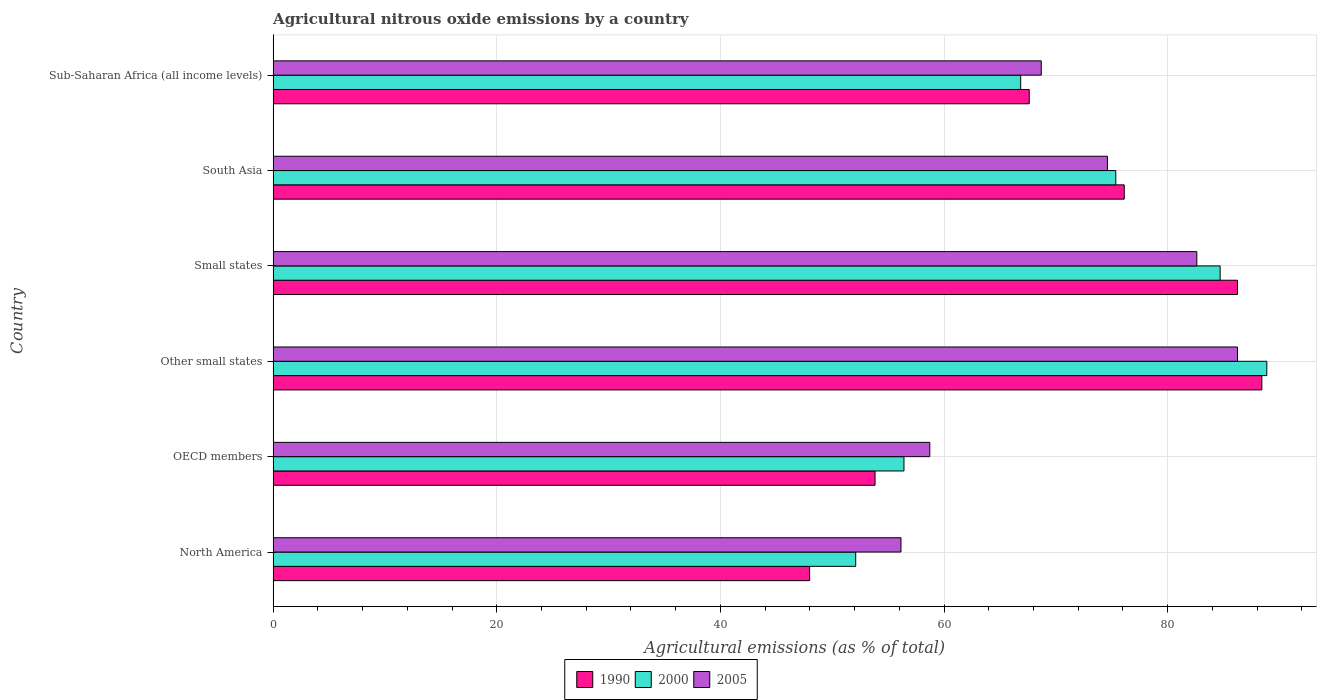How many groups of bars are there?
Offer a very short reply. 6. Are the number of bars on each tick of the Y-axis equal?
Your response must be concise. Yes. How many bars are there on the 2nd tick from the bottom?
Offer a terse response. 3. What is the amount of agricultural nitrous oxide emitted in 2005 in Sub-Saharan Africa (all income levels)?
Your response must be concise. 68.7. Across all countries, what is the maximum amount of agricultural nitrous oxide emitted in 1990?
Offer a very short reply. 88.42. Across all countries, what is the minimum amount of agricultural nitrous oxide emitted in 1990?
Offer a very short reply. 47.98. In which country was the amount of agricultural nitrous oxide emitted in 1990 maximum?
Offer a very short reply. Other small states. What is the total amount of agricultural nitrous oxide emitted in 2000 in the graph?
Ensure brevity in your answer.  424.3. What is the difference between the amount of agricultural nitrous oxide emitted in 2005 in North America and that in Sub-Saharan Africa (all income levels)?
Provide a short and direct response. -12.54. What is the difference between the amount of agricultural nitrous oxide emitted in 2000 in Sub-Saharan Africa (all income levels) and the amount of agricultural nitrous oxide emitted in 1990 in Small states?
Keep it short and to the point. -19.39. What is the average amount of agricultural nitrous oxide emitted in 2005 per country?
Keep it short and to the point. 71.17. What is the difference between the amount of agricultural nitrous oxide emitted in 2005 and amount of agricultural nitrous oxide emitted in 2000 in OECD members?
Offer a very short reply. 2.31. In how many countries, is the amount of agricultural nitrous oxide emitted in 2000 greater than 72 %?
Offer a very short reply. 3. What is the ratio of the amount of agricultural nitrous oxide emitted in 2005 in North America to that in Other small states?
Offer a very short reply. 0.65. Is the difference between the amount of agricultural nitrous oxide emitted in 2005 in Other small states and South Asia greater than the difference between the amount of agricultural nitrous oxide emitted in 2000 in Other small states and South Asia?
Provide a short and direct response. No. What is the difference between the highest and the second highest amount of agricultural nitrous oxide emitted in 2000?
Provide a short and direct response. 4.17. What is the difference between the highest and the lowest amount of agricultural nitrous oxide emitted in 2000?
Keep it short and to the point. 36.77. In how many countries, is the amount of agricultural nitrous oxide emitted in 1990 greater than the average amount of agricultural nitrous oxide emitted in 1990 taken over all countries?
Offer a terse response. 3. Is the sum of the amount of agricultural nitrous oxide emitted in 2000 in North America and OECD members greater than the maximum amount of agricultural nitrous oxide emitted in 2005 across all countries?
Offer a very short reply. Yes. What does the 2nd bar from the top in North America represents?
Keep it short and to the point. 2000. What does the 1st bar from the bottom in OECD members represents?
Your answer should be compact. 1990. How many countries are there in the graph?
Make the answer very short. 6. Are the values on the major ticks of X-axis written in scientific E-notation?
Your answer should be very brief. No. What is the title of the graph?
Make the answer very short. Agricultural nitrous oxide emissions by a country. Does "2000" appear as one of the legend labels in the graph?
Offer a very short reply. Yes. What is the label or title of the X-axis?
Offer a very short reply. Agricultural emissions (as % of total). What is the label or title of the Y-axis?
Make the answer very short. Country. What is the Agricultural emissions (as % of total) of 1990 in North America?
Provide a succinct answer. 47.98. What is the Agricultural emissions (as % of total) in 2000 in North America?
Give a very brief answer. 52.1. What is the Agricultural emissions (as % of total) of 2005 in North America?
Provide a succinct answer. 56.15. What is the Agricultural emissions (as % of total) of 1990 in OECD members?
Make the answer very short. 53.83. What is the Agricultural emissions (as % of total) of 2000 in OECD members?
Offer a very short reply. 56.42. What is the Agricultural emissions (as % of total) of 2005 in OECD members?
Make the answer very short. 58.73. What is the Agricultural emissions (as % of total) in 1990 in Other small states?
Offer a terse response. 88.42. What is the Agricultural emissions (as % of total) in 2000 in Other small states?
Keep it short and to the point. 88.87. What is the Agricultural emissions (as % of total) in 2005 in Other small states?
Ensure brevity in your answer.  86.25. What is the Agricultural emissions (as % of total) in 1990 in Small states?
Ensure brevity in your answer.  86.24. What is the Agricultural emissions (as % of total) of 2000 in Small states?
Offer a terse response. 84.69. What is the Agricultural emissions (as % of total) in 2005 in Small states?
Keep it short and to the point. 82.61. What is the Agricultural emissions (as % of total) in 1990 in South Asia?
Give a very brief answer. 76.12. What is the Agricultural emissions (as % of total) in 2000 in South Asia?
Offer a terse response. 75.36. What is the Agricultural emissions (as % of total) in 2005 in South Asia?
Give a very brief answer. 74.62. What is the Agricultural emissions (as % of total) in 1990 in Sub-Saharan Africa (all income levels)?
Offer a terse response. 67.62. What is the Agricultural emissions (as % of total) in 2000 in Sub-Saharan Africa (all income levels)?
Make the answer very short. 66.86. What is the Agricultural emissions (as % of total) of 2005 in Sub-Saharan Africa (all income levels)?
Make the answer very short. 68.7. Across all countries, what is the maximum Agricultural emissions (as % of total) of 1990?
Your answer should be very brief. 88.42. Across all countries, what is the maximum Agricultural emissions (as % of total) of 2000?
Provide a short and direct response. 88.87. Across all countries, what is the maximum Agricultural emissions (as % of total) in 2005?
Give a very brief answer. 86.25. Across all countries, what is the minimum Agricultural emissions (as % of total) of 1990?
Your response must be concise. 47.98. Across all countries, what is the minimum Agricultural emissions (as % of total) of 2000?
Your answer should be compact. 52.1. Across all countries, what is the minimum Agricultural emissions (as % of total) in 2005?
Offer a very short reply. 56.15. What is the total Agricultural emissions (as % of total) of 1990 in the graph?
Ensure brevity in your answer.  420.22. What is the total Agricultural emissions (as % of total) in 2000 in the graph?
Your response must be concise. 424.3. What is the total Agricultural emissions (as % of total) of 2005 in the graph?
Your answer should be compact. 427.05. What is the difference between the Agricultural emissions (as % of total) in 1990 in North America and that in OECD members?
Your response must be concise. -5.85. What is the difference between the Agricultural emissions (as % of total) in 2000 in North America and that in OECD members?
Provide a succinct answer. -4.32. What is the difference between the Agricultural emissions (as % of total) in 2005 in North America and that in OECD members?
Make the answer very short. -2.58. What is the difference between the Agricultural emissions (as % of total) of 1990 in North America and that in Other small states?
Offer a terse response. -40.44. What is the difference between the Agricultural emissions (as % of total) of 2000 in North America and that in Other small states?
Your answer should be compact. -36.77. What is the difference between the Agricultural emissions (as % of total) in 2005 in North America and that in Other small states?
Give a very brief answer. -30.09. What is the difference between the Agricultural emissions (as % of total) in 1990 in North America and that in Small states?
Offer a terse response. -38.26. What is the difference between the Agricultural emissions (as % of total) of 2000 in North America and that in Small states?
Offer a terse response. -32.59. What is the difference between the Agricultural emissions (as % of total) of 2005 in North America and that in Small states?
Your answer should be very brief. -26.46. What is the difference between the Agricultural emissions (as % of total) of 1990 in North America and that in South Asia?
Provide a succinct answer. -28.14. What is the difference between the Agricultural emissions (as % of total) of 2000 in North America and that in South Asia?
Give a very brief answer. -23.26. What is the difference between the Agricultural emissions (as % of total) in 2005 in North America and that in South Asia?
Your answer should be compact. -18.46. What is the difference between the Agricultural emissions (as % of total) of 1990 in North America and that in Sub-Saharan Africa (all income levels)?
Keep it short and to the point. -19.64. What is the difference between the Agricultural emissions (as % of total) of 2000 in North America and that in Sub-Saharan Africa (all income levels)?
Offer a terse response. -14.76. What is the difference between the Agricultural emissions (as % of total) in 2005 in North America and that in Sub-Saharan Africa (all income levels)?
Provide a short and direct response. -12.54. What is the difference between the Agricultural emissions (as % of total) of 1990 in OECD members and that in Other small states?
Offer a terse response. -34.59. What is the difference between the Agricultural emissions (as % of total) of 2000 in OECD members and that in Other small states?
Keep it short and to the point. -32.45. What is the difference between the Agricultural emissions (as % of total) of 2005 in OECD members and that in Other small states?
Your response must be concise. -27.52. What is the difference between the Agricultural emissions (as % of total) of 1990 in OECD members and that in Small states?
Provide a succinct answer. -32.41. What is the difference between the Agricultural emissions (as % of total) in 2000 in OECD members and that in Small states?
Your answer should be very brief. -28.28. What is the difference between the Agricultural emissions (as % of total) in 2005 in OECD members and that in Small states?
Offer a very short reply. -23.88. What is the difference between the Agricultural emissions (as % of total) in 1990 in OECD members and that in South Asia?
Provide a short and direct response. -22.29. What is the difference between the Agricultural emissions (as % of total) of 2000 in OECD members and that in South Asia?
Provide a succinct answer. -18.94. What is the difference between the Agricultural emissions (as % of total) of 2005 in OECD members and that in South Asia?
Offer a very short reply. -15.89. What is the difference between the Agricultural emissions (as % of total) in 1990 in OECD members and that in Sub-Saharan Africa (all income levels)?
Your answer should be compact. -13.79. What is the difference between the Agricultural emissions (as % of total) of 2000 in OECD members and that in Sub-Saharan Africa (all income levels)?
Provide a short and direct response. -10.44. What is the difference between the Agricultural emissions (as % of total) in 2005 in OECD members and that in Sub-Saharan Africa (all income levels)?
Your answer should be very brief. -9.97. What is the difference between the Agricultural emissions (as % of total) of 1990 in Other small states and that in Small states?
Offer a terse response. 2.18. What is the difference between the Agricultural emissions (as % of total) of 2000 in Other small states and that in Small states?
Offer a very short reply. 4.17. What is the difference between the Agricultural emissions (as % of total) of 2005 in Other small states and that in Small states?
Provide a short and direct response. 3.64. What is the difference between the Agricultural emissions (as % of total) of 1990 in Other small states and that in South Asia?
Offer a terse response. 12.31. What is the difference between the Agricultural emissions (as % of total) of 2000 in Other small states and that in South Asia?
Provide a short and direct response. 13.51. What is the difference between the Agricultural emissions (as % of total) of 2005 in Other small states and that in South Asia?
Keep it short and to the point. 11.63. What is the difference between the Agricultural emissions (as % of total) of 1990 in Other small states and that in Sub-Saharan Africa (all income levels)?
Your response must be concise. 20.8. What is the difference between the Agricultural emissions (as % of total) of 2000 in Other small states and that in Sub-Saharan Africa (all income levels)?
Your answer should be very brief. 22.01. What is the difference between the Agricultural emissions (as % of total) of 2005 in Other small states and that in Sub-Saharan Africa (all income levels)?
Ensure brevity in your answer.  17.55. What is the difference between the Agricultural emissions (as % of total) of 1990 in Small states and that in South Asia?
Your response must be concise. 10.12. What is the difference between the Agricultural emissions (as % of total) in 2000 in Small states and that in South Asia?
Provide a short and direct response. 9.33. What is the difference between the Agricultural emissions (as % of total) of 2005 in Small states and that in South Asia?
Provide a succinct answer. 7.99. What is the difference between the Agricultural emissions (as % of total) of 1990 in Small states and that in Sub-Saharan Africa (all income levels)?
Offer a very short reply. 18.62. What is the difference between the Agricultural emissions (as % of total) of 2000 in Small states and that in Sub-Saharan Africa (all income levels)?
Ensure brevity in your answer.  17.84. What is the difference between the Agricultural emissions (as % of total) in 2005 in Small states and that in Sub-Saharan Africa (all income levels)?
Keep it short and to the point. 13.91. What is the difference between the Agricultural emissions (as % of total) in 1990 in South Asia and that in Sub-Saharan Africa (all income levels)?
Your response must be concise. 8.5. What is the difference between the Agricultural emissions (as % of total) in 2000 in South Asia and that in Sub-Saharan Africa (all income levels)?
Your answer should be very brief. 8.5. What is the difference between the Agricultural emissions (as % of total) of 2005 in South Asia and that in Sub-Saharan Africa (all income levels)?
Offer a very short reply. 5.92. What is the difference between the Agricultural emissions (as % of total) of 1990 in North America and the Agricultural emissions (as % of total) of 2000 in OECD members?
Keep it short and to the point. -8.44. What is the difference between the Agricultural emissions (as % of total) in 1990 in North America and the Agricultural emissions (as % of total) in 2005 in OECD members?
Provide a succinct answer. -10.75. What is the difference between the Agricultural emissions (as % of total) of 2000 in North America and the Agricultural emissions (as % of total) of 2005 in OECD members?
Keep it short and to the point. -6.63. What is the difference between the Agricultural emissions (as % of total) in 1990 in North America and the Agricultural emissions (as % of total) in 2000 in Other small states?
Give a very brief answer. -40.89. What is the difference between the Agricultural emissions (as % of total) in 1990 in North America and the Agricultural emissions (as % of total) in 2005 in Other small states?
Make the answer very short. -38.26. What is the difference between the Agricultural emissions (as % of total) of 2000 in North America and the Agricultural emissions (as % of total) of 2005 in Other small states?
Ensure brevity in your answer.  -34.14. What is the difference between the Agricultural emissions (as % of total) in 1990 in North America and the Agricultural emissions (as % of total) in 2000 in Small states?
Keep it short and to the point. -36.71. What is the difference between the Agricultural emissions (as % of total) in 1990 in North America and the Agricultural emissions (as % of total) in 2005 in Small states?
Make the answer very short. -34.63. What is the difference between the Agricultural emissions (as % of total) in 2000 in North America and the Agricultural emissions (as % of total) in 2005 in Small states?
Give a very brief answer. -30.51. What is the difference between the Agricultural emissions (as % of total) of 1990 in North America and the Agricultural emissions (as % of total) of 2000 in South Asia?
Offer a terse response. -27.38. What is the difference between the Agricultural emissions (as % of total) in 1990 in North America and the Agricultural emissions (as % of total) in 2005 in South Asia?
Make the answer very short. -26.64. What is the difference between the Agricultural emissions (as % of total) in 2000 in North America and the Agricultural emissions (as % of total) in 2005 in South Asia?
Your answer should be very brief. -22.51. What is the difference between the Agricultural emissions (as % of total) of 1990 in North America and the Agricultural emissions (as % of total) of 2000 in Sub-Saharan Africa (all income levels)?
Your answer should be very brief. -18.88. What is the difference between the Agricultural emissions (as % of total) in 1990 in North America and the Agricultural emissions (as % of total) in 2005 in Sub-Saharan Africa (all income levels)?
Offer a very short reply. -20.72. What is the difference between the Agricultural emissions (as % of total) in 2000 in North America and the Agricultural emissions (as % of total) in 2005 in Sub-Saharan Africa (all income levels)?
Keep it short and to the point. -16.6. What is the difference between the Agricultural emissions (as % of total) of 1990 in OECD members and the Agricultural emissions (as % of total) of 2000 in Other small states?
Keep it short and to the point. -35.04. What is the difference between the Agricultural emissions (as % of total) in 1990 in OECD members and the Agricultural emissions (as % of total) in 2005 in Other small states?
Keep it short and to the point. -32.41. What is the difference between the Agricultural emissions (as % of total) of 2000 in OECD members and the Agricultural emissions (as % of total) of 2005 in Other small states?
Your answer should be compact. -29.83. What is the difference between the Agricultural emissions (as % of total) in 1990 in OECD members and the Agricultural emissions (as % of total) in 2000 in Small states?
Offer a very short reply. -30.86. What is the difference between the Agricultural emissions (as % of total) in 1990 in OECD members and the Agricultural emissions (as % of total) in 2005 in Small states?
Give a very brief answer. -28.78. What is the difference between the Agricultural emissions (as % of total) of 2000 in OECD members and the Agricultural emissions (as % of total) of 2005 in Small states?
Offer a terse response. -26.19. What is the difference between the Agricultural emissions (as % of total) in 1990 in OECD members and the Agricultural emissions (as % of total) in 2000 in South Asia?
Offer a very short reply. -21.53. What is the difference between the Agricultural emissions (as % of total) in 1990 in OECD members and the Agricultural emissions (as % of total) in 2005 in South Asia?
Your response must be concise. -20.78. What is the difference between the Agricultural emissions (as % of total) of 2000 in OECD members and the Agricultural emissions (as % of total) of 2005 in South Asia?
Give a very brief answer. -18.2. What is the difference between the Agricultural emissions (as % of total) of 1990 in OECD members and the Agricultural emissions (as % of total) of 2000 in Sub-Saharan Africa (all income levels)?
Your answer should be very brief. -13.03. What is the difference between the Agricultural emissions (as % of total) of 1990 in OECD members and the Agricultural emissions (as % of total) of 2005 in Sub-Saharan Africa (all income levels)?
Offer a very short reply. -14.86. What is the difference between the Agricultural emissions (as % of total) of 2000 in OECD members and the Agricultural emissions (as % of total) of 2005 in Sub-Saharan Africa (all income levels)?
Give a very brief answer. -12.28. What is the difference between the Agricultural emissions (as % of total) of 1990 in Other small states and the Agricultural emissions (as % of total) of 2000 in Small states?
Your response must be concise. 3.73. What is the difference between the Agricultural emissions (as % of total) of 1990 in Other small states and the Agricultural emissions (as % of total) of 2005 in Small states?
Provide a succinct answer. 5.82. What is the difference between the Agricultural emissions (as % of total) in 2000 in Other small states and the Agricultural emissions (as % of total) in 2005 in Small states?
Your answer should be compact. 6.26. What is the difference between the Agricultural emissions (as % of total) of 1990 in Other small states and the Agricultural emissions (as % of total) of 2000 in South Asia?
Offer a very short reply. 13.06. What is the difference between the Agricultural emissions (as % of total) of 1990 in Other small states and the Agricultural emissions (as % of total) of 2005 in South Asia?
Your response must be concise. 13.81. What is the difference between the Agricultural emissions (as % of total) in 2000 in Other small states and the Agricultural emissions (as % of total) in 2005 in South Asia?
Provide a succinct answer. 14.25. What is the difference between the Agricultural emissions (as % of total) in 1990 in Other small states and the Agricultural emissions (as % of total) in 2000 in Sub-Saharan Africa (all income levels)?
Offer a terse response. 21.57. What is the difference between the Agricultural emissions (as % of total) in 1990 in Other small states and the Agricultural emissions (as % of total) in 2005 in Sub-Saharan Africa (all income levels)?
Your answer should be very brief. 19.73. What is the difference between the Agricultural emissions (as % of total) in 2000 in Other small states and the Agricultural emissions (as % of total) in 2005 in Sub-Saharan Africa (all income levels)?
Provide a short and direct response. 20.17. What is the difference between the Agricultural emissions (as % of total) in 1990 in Small states and the Agricultural emissions (as % of total) in 2000 in South Asia?
Make the answer very short. 10.88. What is the difference between the Agricultural emissions (as % of total) of 1990 in Small states and the Agricultural emissions (as % of total) of 2005 in South Asia?
Your answer should be compact. 11.63. What is the difference between the Agricultural emissions (as % of total) of 2000 in Small states and the Agricultural emissions (as % of total) of 2005 in South Asia?
Make the answer very short. 10.08. What is the difference between the Agricultural emissions (as % of total) of 1990 in Small states and the Agricultural emissions (as % of total) of 2000 in Sub-Saharan Africa (all income levels)?
Provide a succinct answer. 19.39. What is the difference between the Agricultural emissions (as % of total) of 1990 in Small states and the Agricultural emissions (as % of total) of 2005 in Sub-Saharan Africa (all income levels)?
Give a very brief answer. 17.55. What is the difference between the Agricultural emissions (as % of total) of 2000 in Small states and the Agricultural emissions (as % of total) of 2005 in Sub-Saharan Africa (all income levels)?
Provide a short and direct response. 16. What is the difference between the Agricultural emissions (as % of total) of 1990 in South Asia and the Agricultural emissions (as % of total) of 2000 in Sub-Saharan Africa (all income levels)?
Provide a succinct answer. 9.26. What is the difference between the Agricultural emissions (as % of total) in 1990 in South Asia and the Agricultural emissions (as % of total) in 2005 in Sub-Saharan Africa (all income levels)?
Offer a very short reply. 7.42. What is the difference between the Agricultural emissions (as % of total) of 2000 in South Asia and the Agricultural emissions (as % of total) of 2005 in Sub-Saharan Africa (all income levels)?
Offer a terse response. 6.67. What is the average Agricultural emissions (as % of total) of 1990 per country?
Provide a succinct answer. 70.04. What is the average Agricultural emissions (as % of total) in 2000 per country?
Provide a succinct answer. 70.72. What is the average Agricultural emissions (as % of total) of 2005 per country?
Provide a short and direct response. 71.17. What is the difference between the Agricultural emissions (as % of total) in 1990 and Agricultural emissions (as % of total) in 2000 in North America?
Your answer should be compact. -4.12. What is the difference between the Agricultural emissions (as % of total) of 1990 and Agricultural emissions (as % of total) of 2005 in North America?
Your answer should be compact. -8.17. What is the difference between the Agricultural emissions (as % of total) of 2000 and Agricultural emissions (as % of total) of 2005 in North America?
Your answer should be very brief. -4.05. What is the difference between the Agricultural emissions (as % of total) of 1990 and Agricultural emissions (as % of total) of 2000 in OECD members?
Make the answer very short. -2.59. What is the difference between the Agricultural emissions (as % of total) of 1990 and Agricultural emissions (as % of total) of 2005 in OECD members?
Give a very brief answer. -4.9. What is the difference between the Agricultural emissions (as % of total) in 2000 and Agricultural emissions (as % of total) in 2005 in OECD members?
Offer a terse response. -2.31. What is the difference between the Agricultural emissions (as % of total) in 1990 and Agricultural emissions (as % of total) in 2000 in Other small states?
Give a very brief answer. -0.44. What is the difference between the Agricultural emissions (as % of total) in 1990 and Agricultural emissions (as % of total) in 2005 in Other small states?
Your answer should be very brief. 2.18. What is the difference between the Agricultural emissions (as % of total) of 2000 and Agricultural emissions (as % of total) of 2005 in Other small states?
Give a very brief answer. 2.62. What is the difference between the Agricultural emissions (as % of total) in 1990 and Agricultural emissions (as % of total) in 2000 in Small states?
Offer a terse response. 1.55. What is the difference between the Agricultural emissions (as % of total) in 1990 and Agricultural emissions (as % of total) in 2005 in Small states?
Your answer should be compact. 3.64. What is the difference between the Agricultural emissions (as % of total) in 2000 and Agricultural emissions (as % of total) in 2005 in Small states?
Your answer should be very brief. 2.09. What is the difference between the Agricultural emissions (as % of total) in 1990 and Agricultural emissions (as % of total) in 2000 in South Asia?
Your answer should be very brief. 0.76. What is the difference between the Agricultural emissions (as % of total) of 1990 and Agricultural emissions (as % of total) of 2005 in South Asia?
Give a very brief answer. 1.5. What is the difference between the Agricultural emissions (as % of total) of 2000 and Agricultural emissions (as % of total) of 2005 in South Asia?
Keep it short and to the point. 0.75. What is the difference between the Agricultural emissions (as % of total) in 1990 and Agricultural emissions (as % of total) in 2000 in Sub-Saharan Africa (all income levels)?
Your answer should be compact. 0.76. What is the difference between the Agricultural emissions (as % of total) of 1990 and Agricultural emissions (as % of total) of 2005 in Sub-Saharan Africa (all income levels)?
Offer a terse response. -1.08. What is the difference between the Agricultural emissions (as % of total) of 2000 and Agricultural emissions (as % of total) of 2005 in Sub-Saharan Africa (all income levels)?
Give a very brief answer. -1.84. What is the ratio of the Agricultural emissions (as % of total) of 1990 in North America to that in OECD members?
Provide a succinct answer. 0.89. What is the ratio of the Agricultural emissions (as % of total) in 2000 in North America to that in OECD members?
Ensure brevity in your answer.  0.92. What is the ratio of the Agricultural emissions (as % of total) of 2005 in North America to that in OECD members?
Give a very brief answer. 0.96. What is the ratio of the Agricultural emissions (as % of total) of 1990 in North America to that in Other small states?
Ensure brevity in your answer.  0.54. What is the ratio of the Agricultural emissions (as % of total) in 2000 in North America to that in Other small states?
Keep it short and to the point. 0.59. What is the ratio of the Agricultural emissions (as % of total) of 2005 in North America to that in Other small states?
Keep it short and to the point. 0.65. What is the ratio of the Agricultural emissions (as % of total) in 1990 in North America to that in Small states?
Make the answer very short. 0.56. What is the ratio of the Agricultural emissions (as % of total) of 2000 in North America to that in Small states?
Offer a very short reply. 0.62. What is the ratio of the Agricultural emissions (as % of total) in 2005 in North America to that in Small states?
Make the answer very short. 0.68. What is the ratio of the Agricultural emissions (as % of total) of 1990 in North America to that in South Asia?
Offer a very short reply. 0.63. What is the ratio of the Agricultural emissions (as % of total) of 2000 in North America to that in South Asia?
Your answer should be very brief. 0.69. What is the ratio of the Agricultural emissions (as % of total) in 2005 in North America to that in South Asia?
Your answer should be compact. 0.75. What is the ratio of the Agricultural emissions (as % of total) of 1990 in North America to that in Sub-Saharan Africa (all income levels)?
Your answer should be very brief. 0.71. What is the ratio of the Agricultural emissions (as % of total) of 2000 in North America to that in Sub-Saharan Africa (all income levels)?
Offer a terse response. 0.78. What is the ratio of the Agricultural emissions (as % of total) in 2005 in North America to that in Sub-Saharan Africa (all income levels)?
Give a very brief answer. 0.82. What is the ratio of the Agricultural emissions (as % of total) in 1990 in OECD members to that in Other small states?
Give a very brief answer. 0.61. What is the ratio of the Agricultural emissions (as % of total) in 2000 in OECD members to that in Other small states?
Provide a succinct answer. 0.63. What is the ratio of the Agricultural emissions (as % of total) of 2005 in OECD members to that in Other small states?
Ensure brevity in your answer.  0.68. What is the ratio of the Agricultural emissions (as % of total) of 1990 in OECD members to that in Small states?
Offer a very short reply. 0.62. What is the ratio of the Agricultural emissions (as % of total) of 2000 in OECD members to that in Small states?
Your answer should be compact. 0.67. What is the ratio of the Agricultural emissions (as % of total) in 2005 in OECD members to that in Small states?
Make the answer very short. 0.71. What is the ratio of the Agricultural emissions (as % of total) in 1990 in OECD members to that in South Asia?
Your answer should be very brief. 0.71. What is the ratio of the Agricultural emissions (as % of total) in 2000 in OECD members to that in South Asia?
Give a very brief answer. 0.75. What is the ratio of the Agricultural emissions (as % of total) in 2005 in OECD members to that in South Asia?
Your answer should be compact. 0.79. What is the ratio of the Agricultural emissions (as % of total) of 1990 in OECD members to that in Sub-Saharan Africa (all income levels)?
Provide a short and direct response. 0.8. What is the ratio of the Agricultural emissions (as % of total) in 2000 in OECD members to that in Sub-Saharan Africa (all income levels)?
Offer a terse response. 0.84. What is the ratio of the Agricultural emissions (as % of total) in 2005 in OECD members to that in Sub-Saharan Africa (all income levels)?
Keep it short and to the point. 0.85. What is the ratio of the Agricultural emissions (as % of total) in 1990 in Other small states to that in Small states?
Offer a very short reply. 1.03. What is the ratio of the Agricultural emissions (as % of total) of 2000 in Other small states to that in Small states?
Your answer should be very brief. 1.05. What is the ratio of the Agricultural emissions (as % of total) of 2005 in Other small states to that in Small states?
Offer a terse response. 1.04. What is the ratio of the Agricultural emissions (as % of total) in 1990 in Other small states to that in South Asia?
Your response must be concise. 1.16. What is the ratio of the Agricultural emissions (as % of total) of 2000 in Other small states to that in South Asia?
Offer a terse response. 1.18. What is the ratio of the Agricultural emissions (as % of total) in 2005 in Other small states to that in South Asia?
Give a very brief answer. 1.16. What is the ratio of the Agricultural emissions (as % of total) in 1990 in Other small states to that in Sub-Saharan Africa (all income levels)?
Your answer should be very brief. 1.31. What is the ratio of the Agricultural emissions (as % of total) in 2000 in Other small states to that in Sub-Saharan Africa (all income levels)?
Your response must be concise. 1.33. What is the ratio of the Agricultural emissions (as % of total) in 2005 in Other small states to that in Sub-Saharan Africa (all income levels)?
Your answer should be very brief. 1.26. What is the ratio of the Agricultural emissions (as % of total) in 1990 in Small states to that in South Asia?
Your answer should be very brief. 1.13. What is the ratio of the Agricultural emissions (as % of total) of 2000 in Small states to that in South Asia?
Ensure brevity in your answer.  1.12. What is the ratio of the Agricultural emissions (as % of total) in 2005 in Small states to that in South Asia?
Ensure brevity in your answer.  1.11. What is the ratio of the Agricultural emissions (as % of total) of 1990 in Small states to that in Sub-Saharan Africa (all income levels)?
Ensure brevity in your answer.  1.28. What is the ratio of the Agricultural emissions (as % of total) of 2000 in Small states to that in Sub-Saharan Africa (all income levels)?
Offer a very short reply. 1.27. What is the ratio of the Agricultural emissions (as % of total) in 2005 in Small states to that in Sub-Saharan Africa (all income levels)?
Provide a succinct answer. 1.2. What is the ratio of the Agricultural emissions (as % of total) in 1990 in South Asia to that in Sub-Saharan Africa (all income levels)?
Keep it short and to the point. 1.13. What is the ratio of the Agricultural emissions (as % of total) of 2000 in South Asia to that in Sub-Saharan Africa (all income levels)?
Offer a very short reply. 1.13. What is the ratio of the Agricultural emissions (as % of total) of 2005 in South Asia to that in Sub-Saharan Africa (all income levels)?
Make the answer very short. 1.09. What is the difference between the highest and the second highest Agricultural emissions (as % of total) in 1990?
Ensure brevity in your answer.  2.18. What is the difference between the highest and the second highest Agricultural emissions (as % of total) in 2000?
Your answer should be compact. 4.17. What is the difference between the highest and the second highest Agricultural emissions (as % of total) of 2005?
Provide a short and direct response. 3.64. What is the difference between the highest and the lowest Agricultural emissions (as % of total) of 1990?
Keep it short and to the point. 40.44. What is the difference between the highest and the lowest Agricultural emissions (as % of total) in 2000?
Your response must be concise. 36.77. What is the difference between the highest and the lowest Agricultural emissions (as % of total) of 2005?
Ensure brevity in your answer.  30.09. 